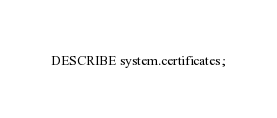<code> <loc_0><loc_0><loc_500><loc_500><_SQL_>DESCRIBE system.certificates;
</code> 